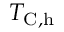<formula> <loc_0><loc_0><loc_500><loc_500>T _ { C , h }</formula> 